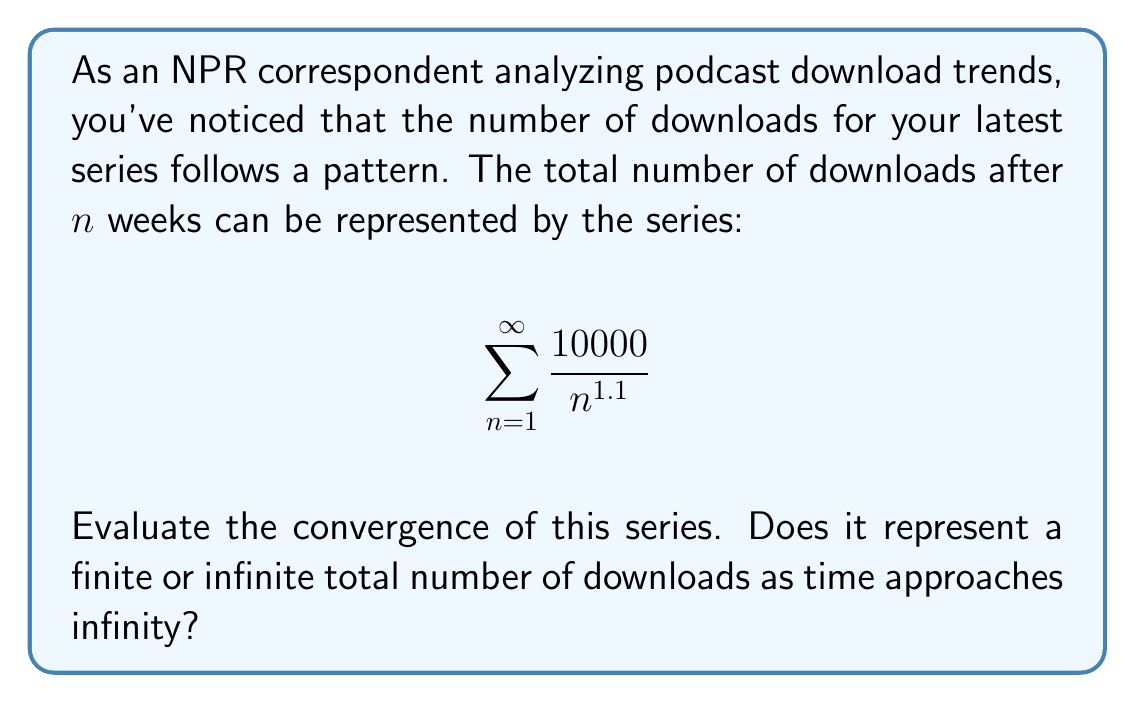Teach me how to tackle this problem. To evaluate the convergence of this series, we'll use the p-series test.

1) The general form of a p-series is:

   $$ \sum_{n=1}^{\infty} \frac{1}{n^p} $$

2) Our series can be rewritten as:

   $$ 10000 \sum_{n=1}^{\infty} \frac{1}{n^{1.1}} $$

3) In this case, $p = 1.1$

4) The p-series test states:
   - If $p > 1$, the series converges
   - If $p \leq 1$, the series diverges

5) Since $1.1 > 1$, this series converges.

6) To interpret this result:
   - Convergence means the sum approaches a finite value as n approaches infinity.
   - In the context of podcast downloads, this suggests that the total number of downloads will approach a finite limit over time.

7) While we can't easily calculate the exact sum, we know it's finite and greater than the first term:

   $$ \sum_{n=1}^{\infty} \frac{10000}{n^{1.1}} > \frac{10000}{1^{1.1}} = 10000 $$

This analysis suggests that while downloads will continue indefinitely, they will do so at a decreasing rate, eventually approaching a maximum total.
Answer: The series converges, representing a finite total number of downloads as time approaches infinity. 